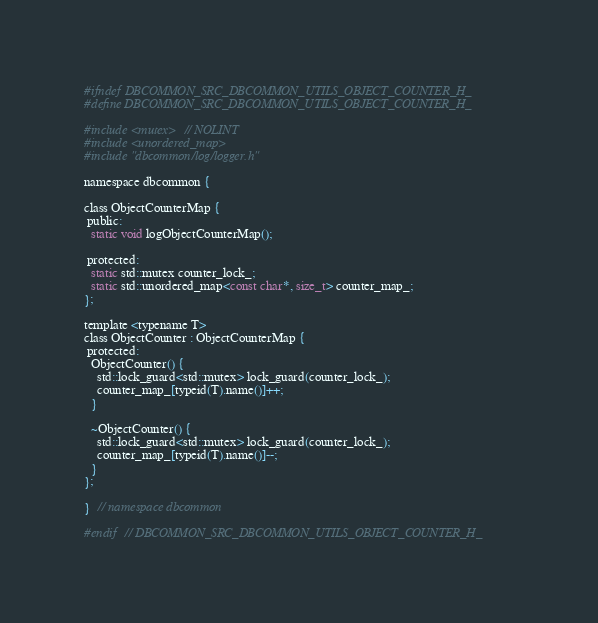Convert code to text. <code><loc_0><loc_0><loc_500><loc_500><_C_>
#ifndef DBCOMMON_SRC_DBCOMMON_UTILS_OBJECT_COUNTER_H_
#define DBCOMMON_SRC_DBCOMMON_UTILS_OBJECT_COUNTER_H_

#include <mutex>  // NOLINT
#include <unordered_map>
#include "dbcommon/log/logger.h"

namespace dbcommon {

class ObjectCounterMap {
 public:
  static void logObjectCounterMap();

 protected:
  static std::mutex counter_lock_;
  static std::unordered_map<const char*, size_t> counter_map_;
};

template <typename T>
class ObjectCounter : ObjectCounterMap {
 protected:
  ObjectCounter() {
    std::lock_guard<std::mutex> lock_guard(counter_lock_);
    counter_map_[typeid(T).name()]++;
  }

  ~ObjectCounter() {
    std::lock_guard<std::mutex> lock_guard(counter_lock_);
    counter_map_[typeid(T).name()]--;
  }
};

}  // namespace dbcommon

#endif  // DBCOMMON_SRC_DBCOMMON_UTILS_OBJECT_COUNTER_H_
</code> 